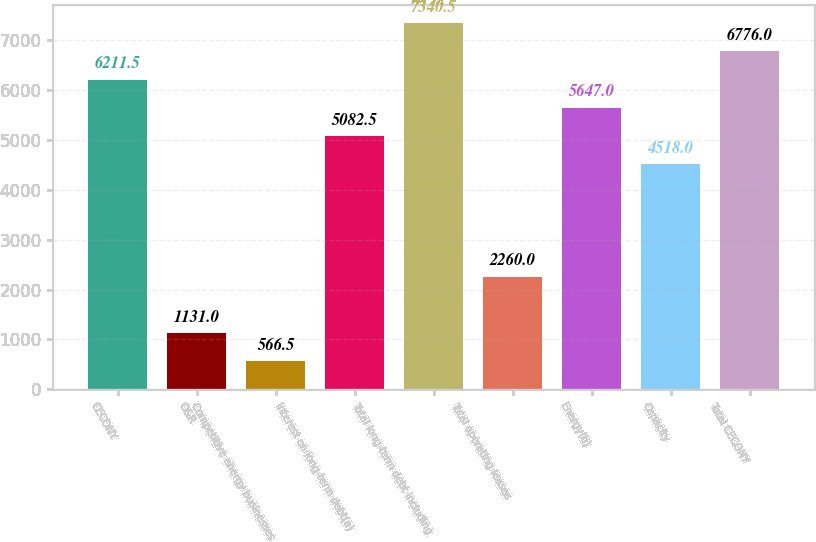Convert chart. <chart><loc_0><loc_0><loc_500><loc_500><bar_chart><fcel>CECONY<fcel>O&R<fcel>Competitive energy businesses<fcel>Interest on long-term debt(a)<fcel>Total long-term debt including<fcel>Total operating leases<fcel>Energy(b)<fcel>Capacity<fcel>Total CECONY<nl><fcel>6211.5<fcel>1131<fcel>566.5<fcel>5082.5<fcel>7340.5<fcel>2260<fcel>5647<fcel>4518<fcel>6776<nl></chart> 